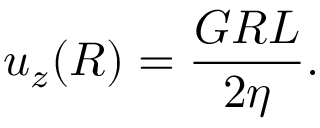Convert formula to latex. <formula><loc_0><loc_0><loc_500><loc_500>u _ { z } ( R ) = \frac { G R L } { 2 \eta } .</formula> 